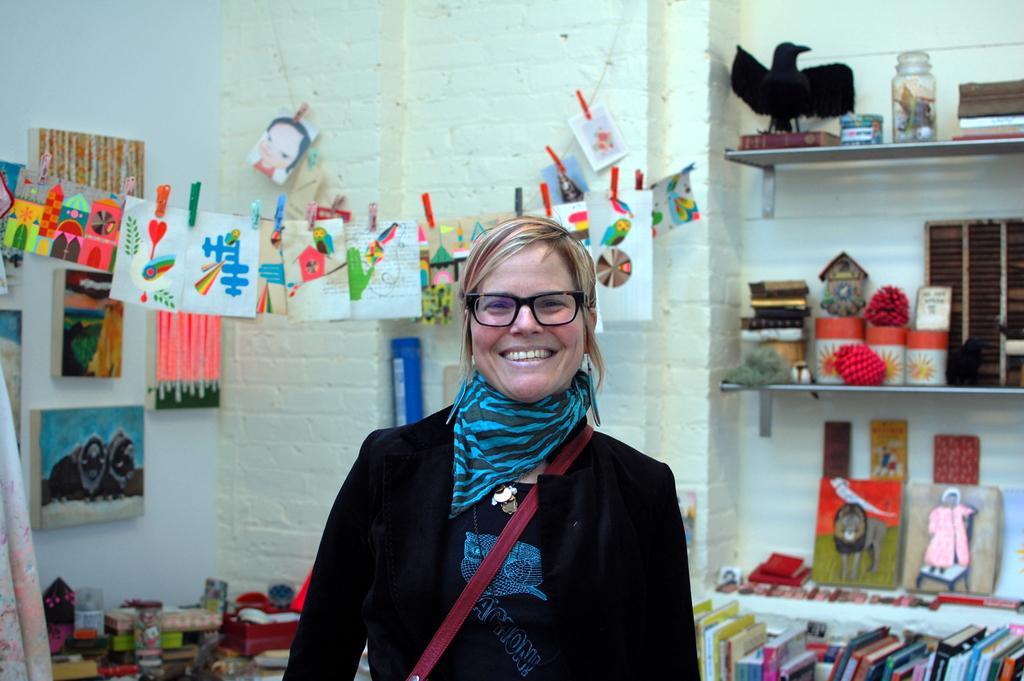How would you summarize this image in a sentence or two? In this image there is a woman. There are cracks on the right side. There are books and papers. There is a wall in the background. 